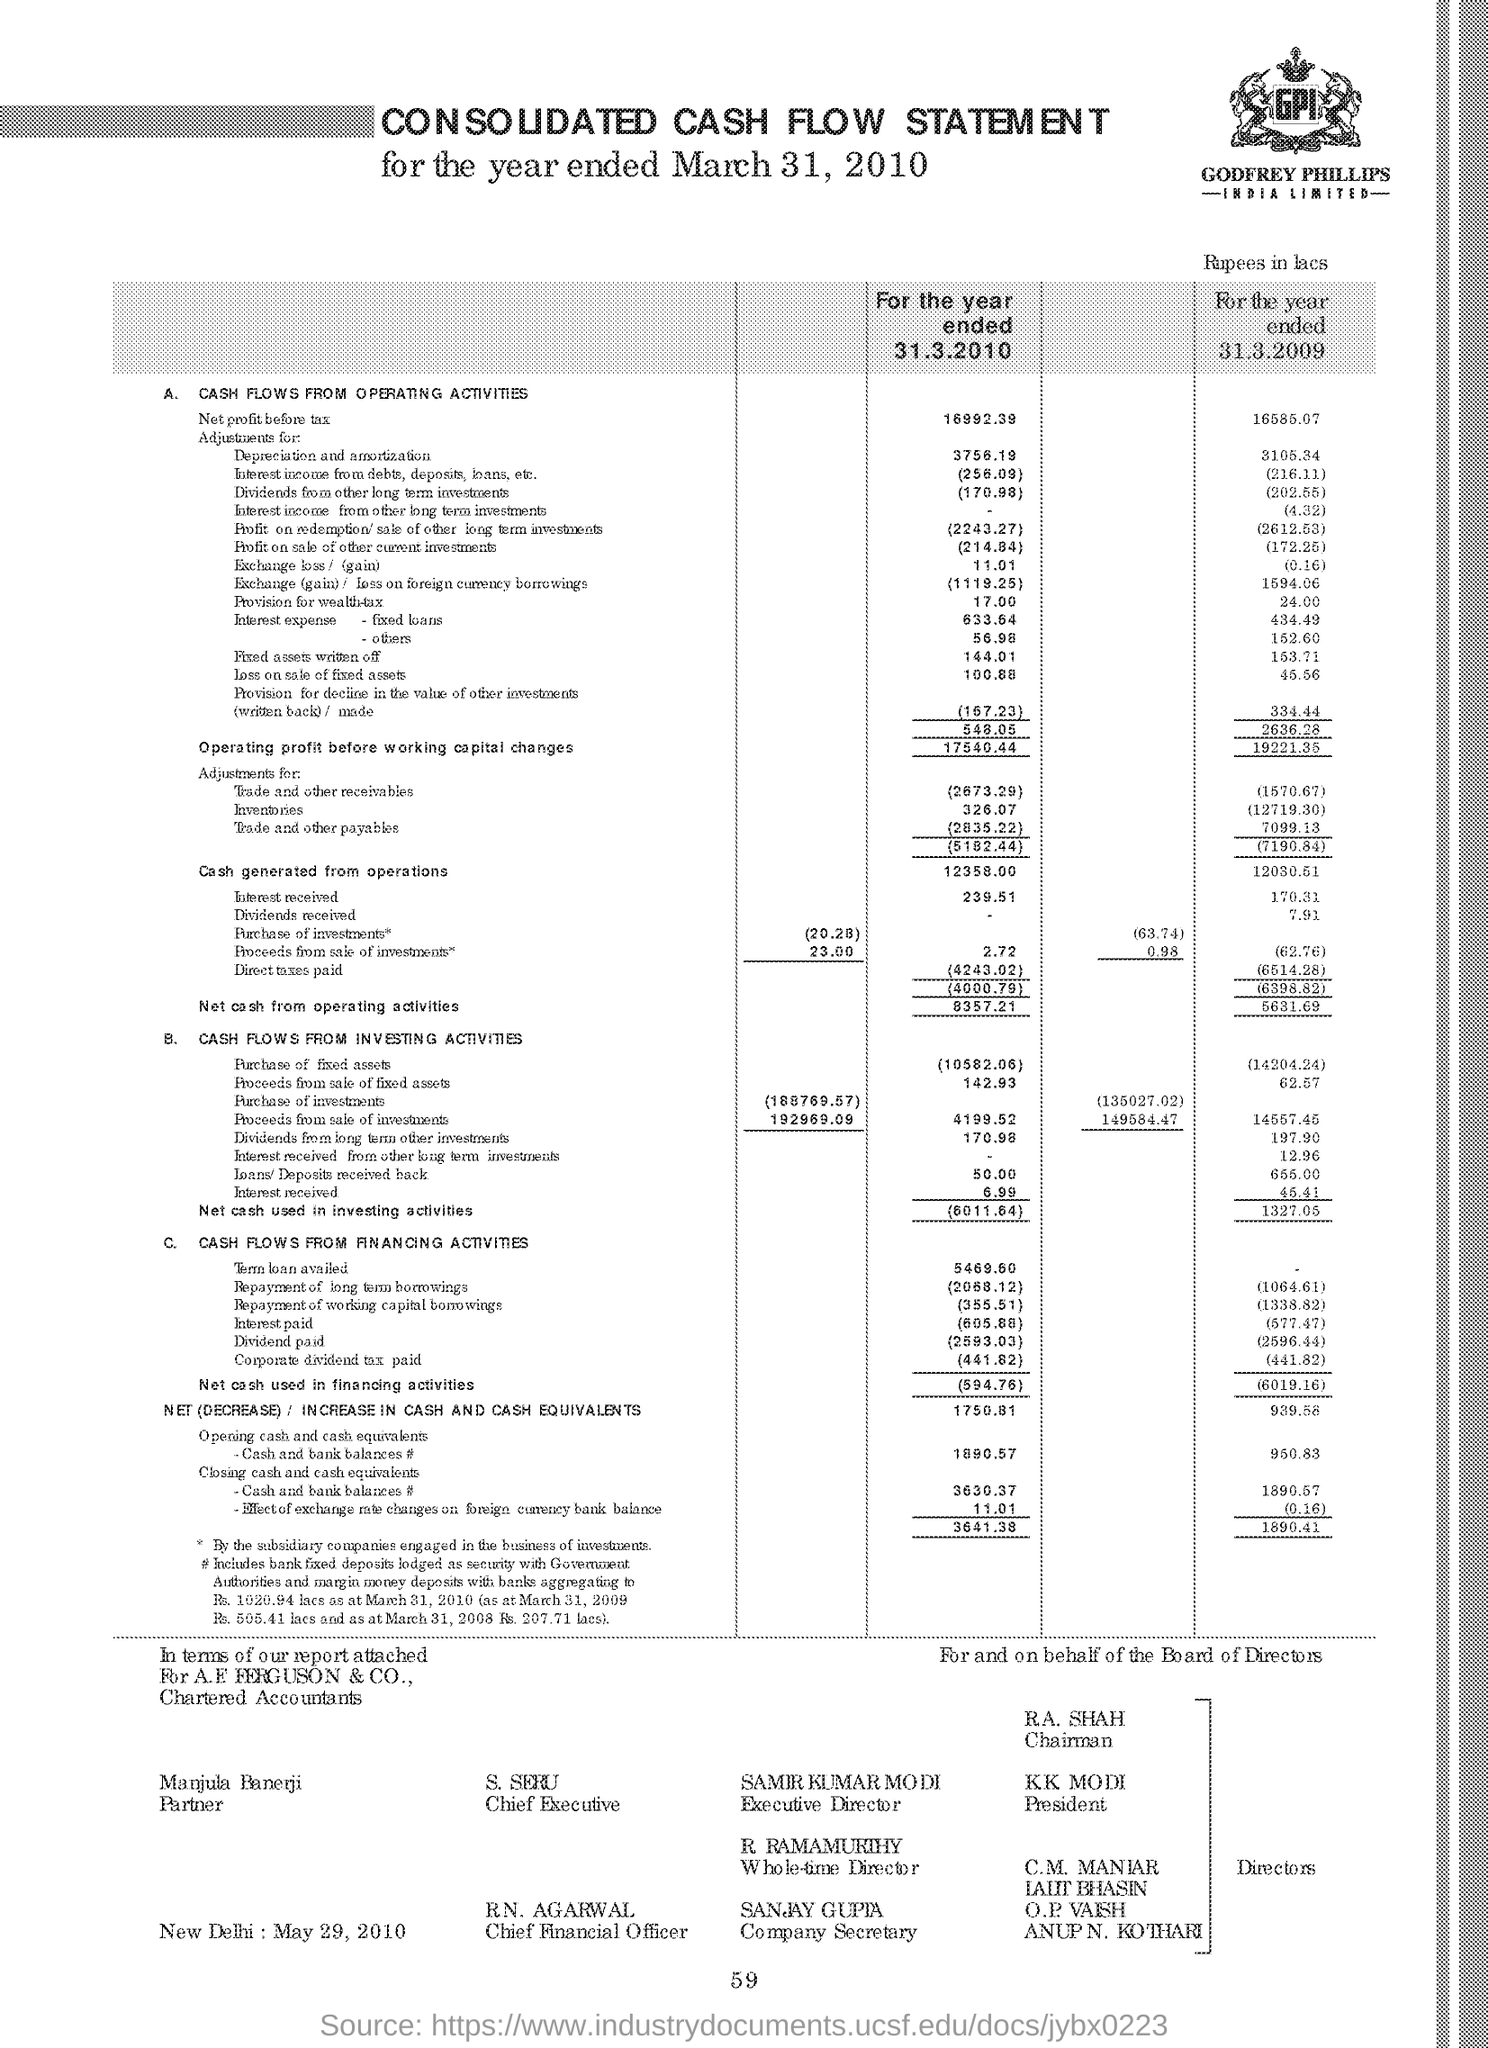Who is the Chairman?
Provide a succinct answer. R.A. Shah. Who is the President?
Your answer should be compact. K.K. Modi. Who is the Company Secretary?
Offer a very short reply. Sanjay Gupta. Who is the Chief Executive?
Ensure brevity in your answer.  S. Seru. Who is the Executive Director?
Your answer should be compact. Samir Kumar Modi. Who is the Whole-time Director?
Offer a very short reply. R Ramamurthy. 